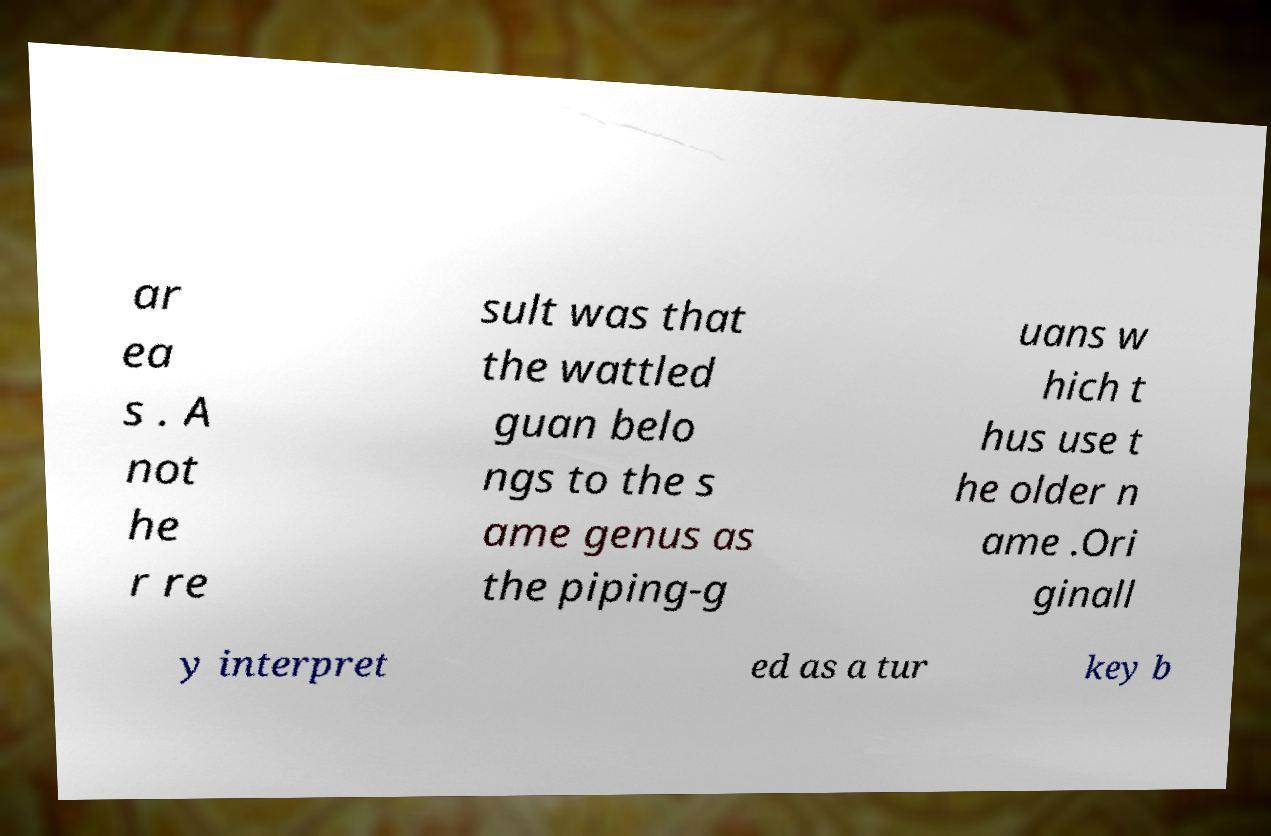Can you read and provide the text displayed in the image?This photo seems to have some interesting text. Can you extract and type it out for me? ar ea s . A not he r re sult was that the wattled guan belo ngs to the s ame genus as the piping-g uans w hich t hus use t he older n ame .Ori ginall y interpret ed as a tur key b 